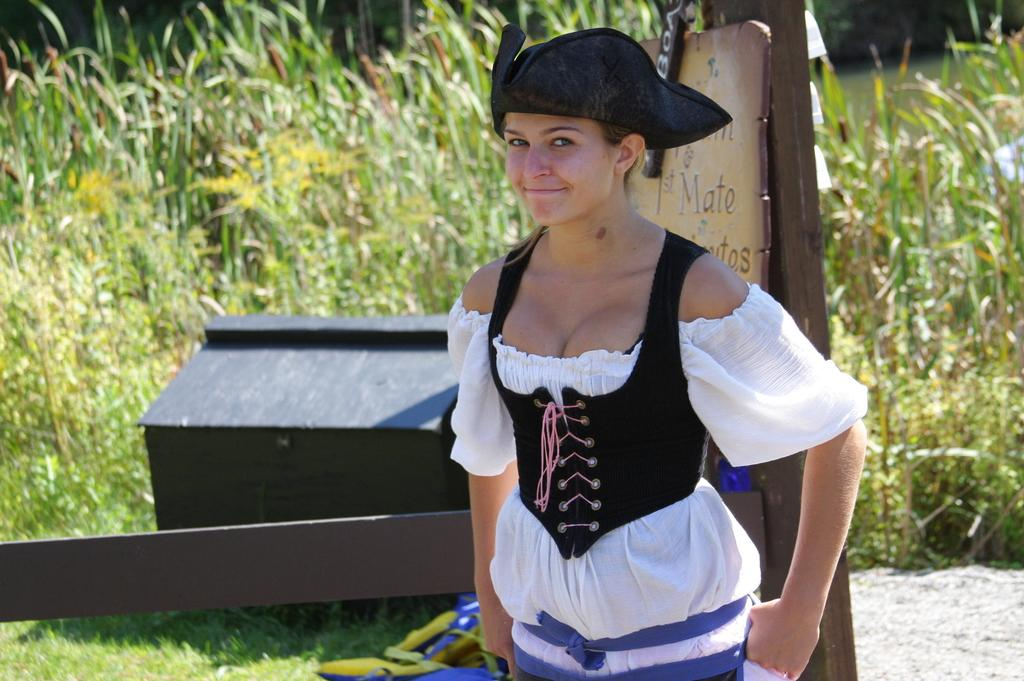<image>
Present a compact description of the photo's key features. A woman wearing a triangular pirat's hat is standing in front of the sign that has the word "mate." 